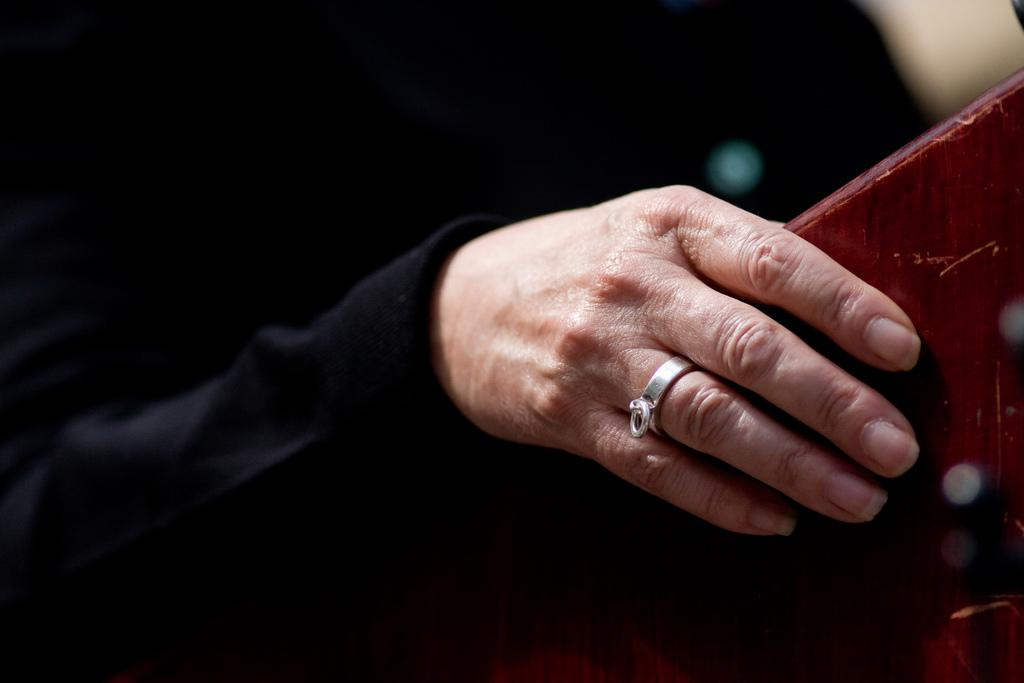What is the person's hand holding in the image? The person's hand is holding an object in the image. Can you describe the background of the image? The background of the image appears dark. What type of beef is being prepared in the image? There is no beef or any indication of food preparation in the image. 